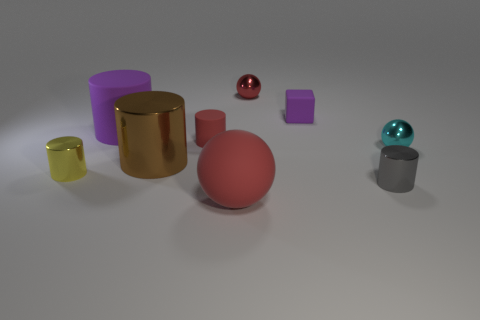What number of cyan metal things have the same size as the gray shiny cylinder?
Your answer should be compact. 1. There is a large object that is the same color as the matte block; what material is it?
Your answer should be very brief. Rubber. Does the cyan thing that is in front of the small purple block have the same shape as the tiny red shiny object?
Make the answer very short. Yes. Are there fewer gray cylinders on the right side of the brown shiny cylinder than large brown metal cylinders?
Provide a short and direct response. No. Are there any small matte objects that have the same color as the matte cube?
Keep it short and to the point. No. Is the shape of the small purple matte object the same as the thing on the right side of the gray object?
Your answer should be compact. No. Is there a tiny gray cylinder made of the same material as the cyan object?
Your answer should be very brief. Yes. There is a cylinder right of the matte object that is on the right side of the large red rubber sphere; are there any purple rubber objects right of it?
Your response must be concise. No. What number of other things are there of the same shape as the brown metal object?
Ensure brevity in your answer.  4. What color is the small metallic cylinder that is to the left of the red matte object that is in front of the tiny sphere to the right of the small purple rubber thing?
Offer a terse response. Yellow. 